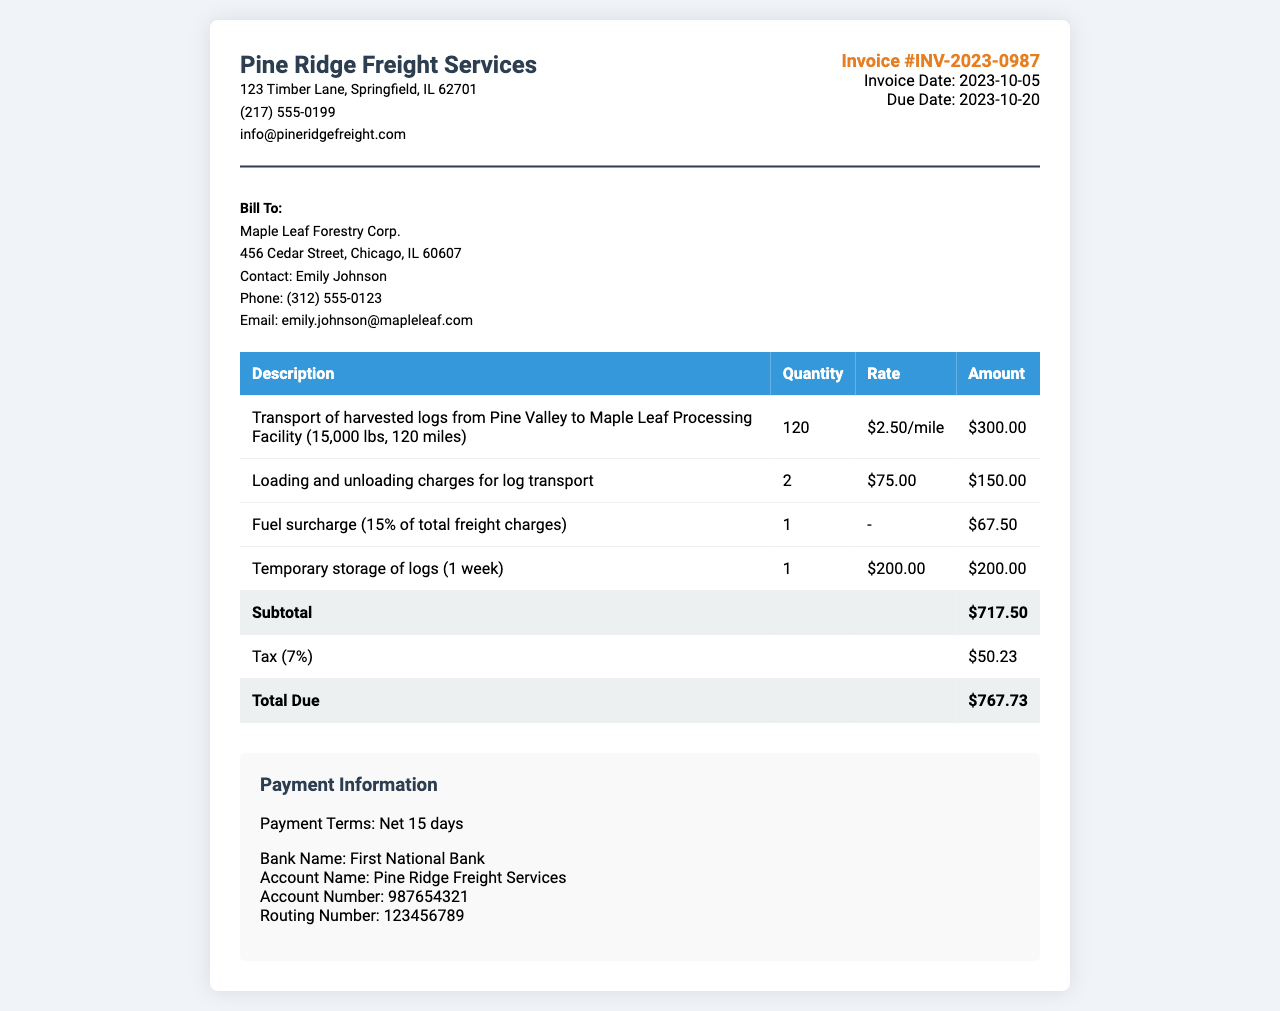What is the invoice number? The invoice number is stated clearly at the top of the document under the invoice info section.
Answer: INV-2023-0987 What is the total due amount? The total due amount is calculated at the bottom of the invoice, summarizing all charges, taxes, and subtotals.
Answer: $767.73 Who is the contact person for Maple Leaf Forestry Corp.? The contact person is listed in the customer details section of the invoice.
Answer: Emily Johnson What is the percentage of the tax applied? The tax is detailed in the invoice under the taxation line item.
Answer: 7% What is the rate per mile for the transport of logs? The rate per mile for the transport is mentioned in the description of the first line item in the table.
Answer: $2.50/mile How much is the fuel surcharge? The fuel surcharge is listed as a specific line item in the invoice table, showing its calculated amount.
Answer: $67.50 What was the subtotal before tax? The subtotal is clearly labeled in the invoice towards the end of the itemized list before tax is added.
Answer: $717.50 What are the payment terms noted in the document? The payment terms are specified in the payment information section at the bottom of the invoice.
Answer: Net 15 days 